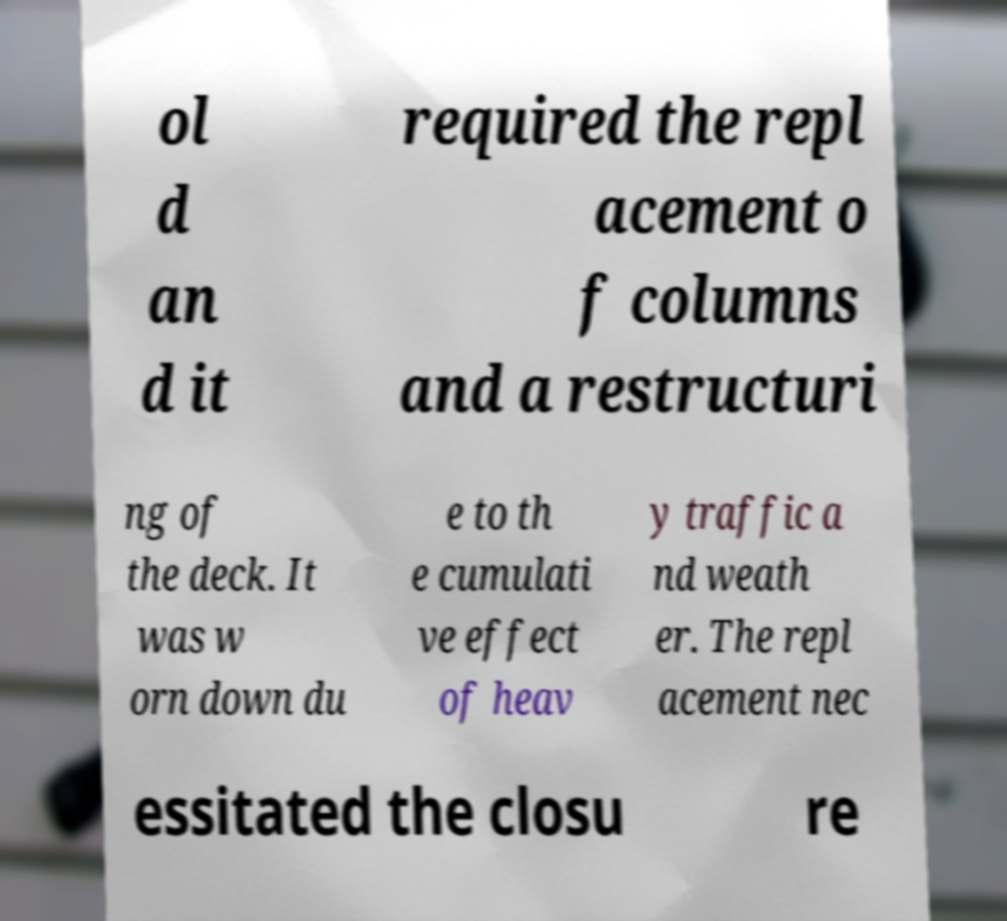What messages or text are displayed in this image? I need them in a readable, typed format. ol d an d it required the repl acement o f columns and a restructuri ng of the deck. It was w orn down du e to th e cumulati ve effect of heav y traffic a nd weath er. The repl acement nec essitated the closu re 